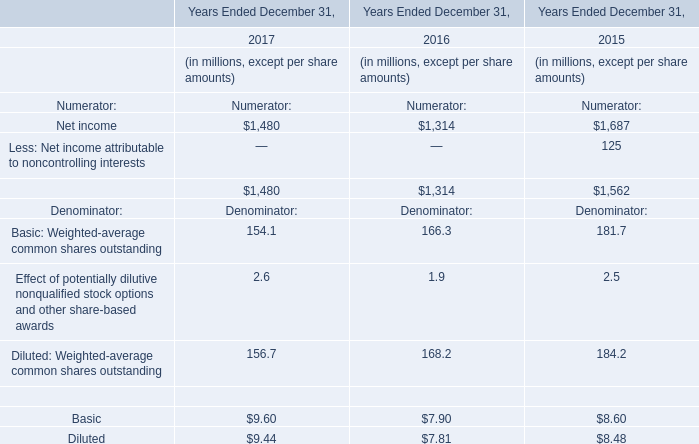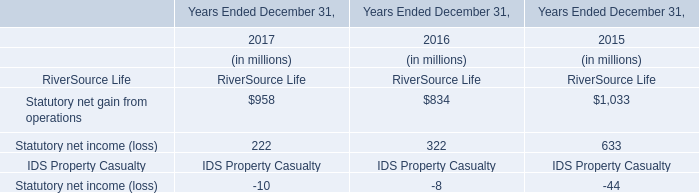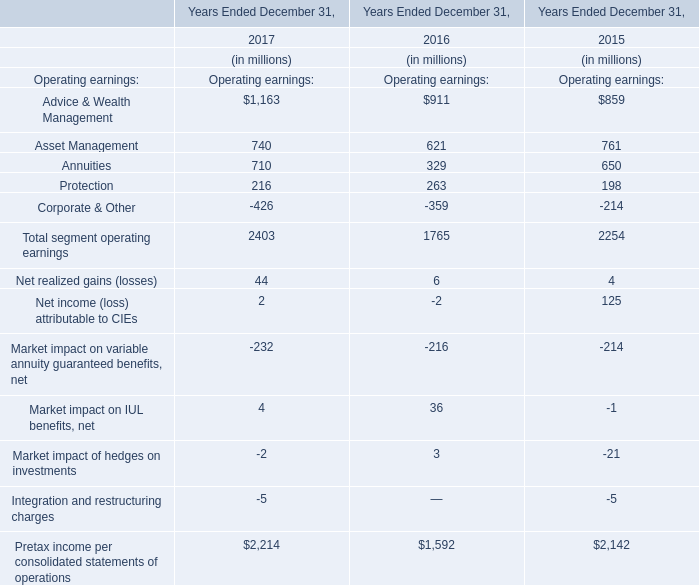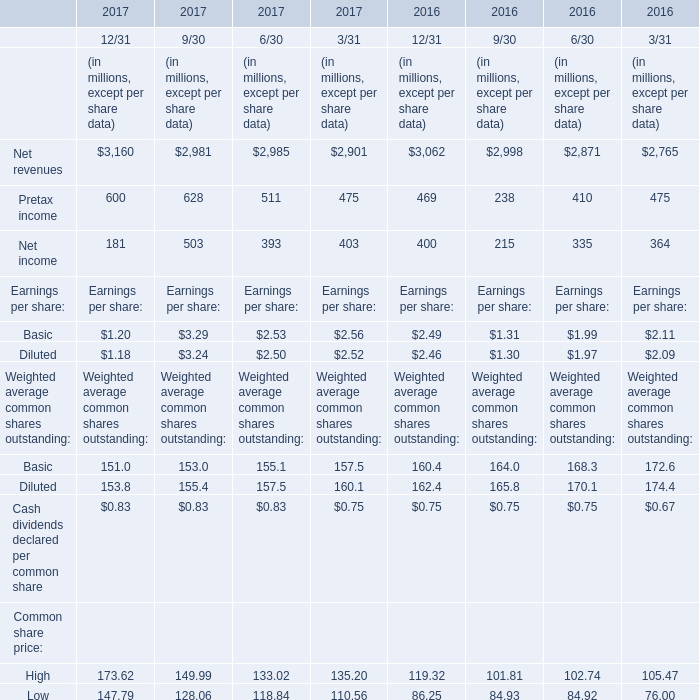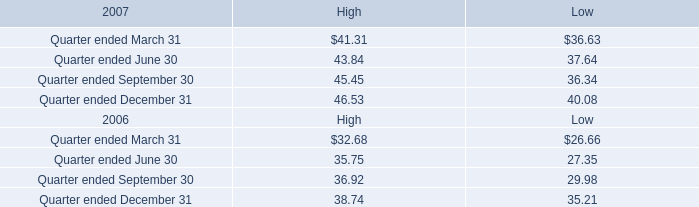what was the fair value of class a stockholders equity at february 29 , 2008?\\n . 
Computations: (38.44 * 395748826)
Answer: 15212584871.44. 